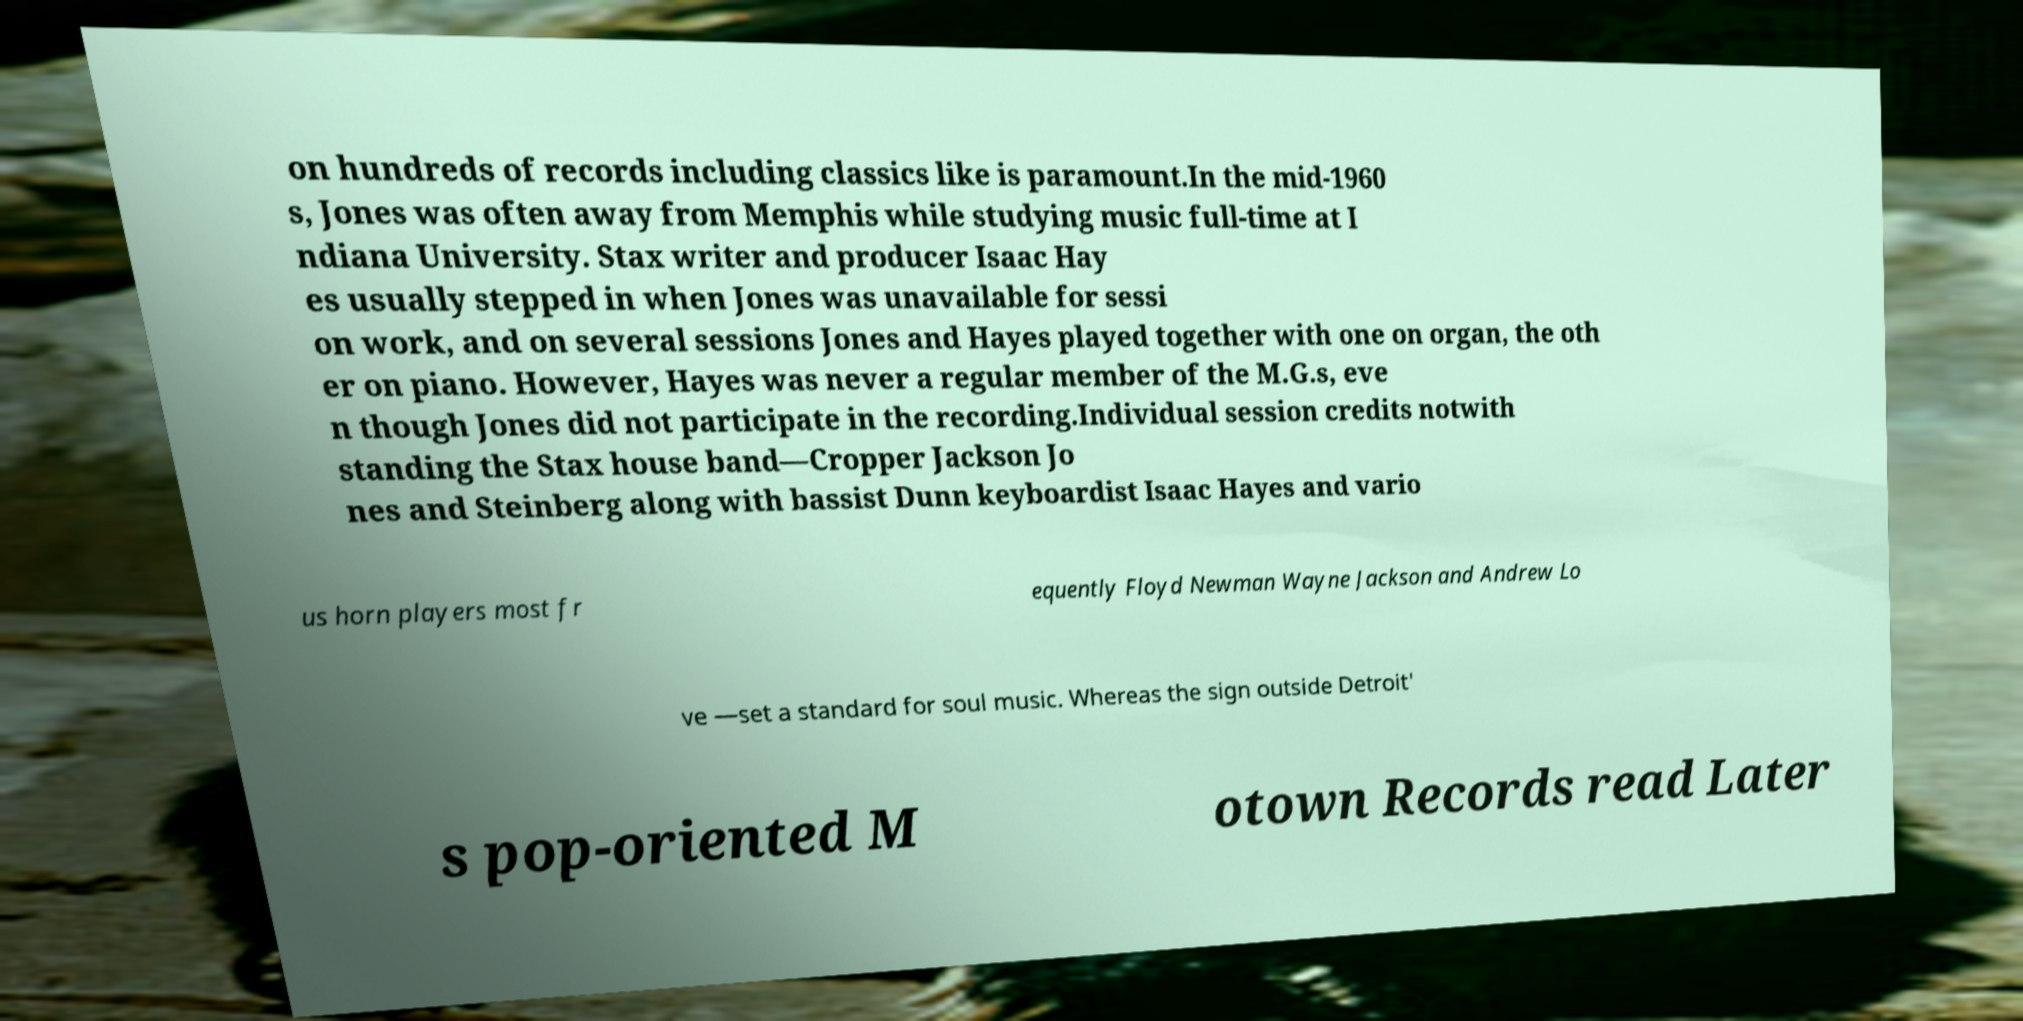There's text embedded in this image that I need extracted. Can you transcribe it verbatim? on hundreds of records including classics like is paramount.In the mid-1960 s, Jones was often away from Memphis while studying music full-time at I ndiana University. Stax writer and producer Isaac Hay es usually stepped in when Jones was unavailable for sessi on work, and on several sessions Jones and Hayes played together with one on organ, the oth er on piano. However, Hayes was never a regular member of the M.G.s, eve n though Jones did not participate in the recording.Individual session credits notwith standing the Stax house band—Cropper Jackson Jo nes and Steinberg along with bassist Dunn keyboardist Isaac Hayes and vario us horn players most fr equently Floyd Newman Wayne Jackson and Andrew Lo ve —set a standard for soul music. Whereas the sign outside Detroit' s pop-oriented M otown Records read Later 